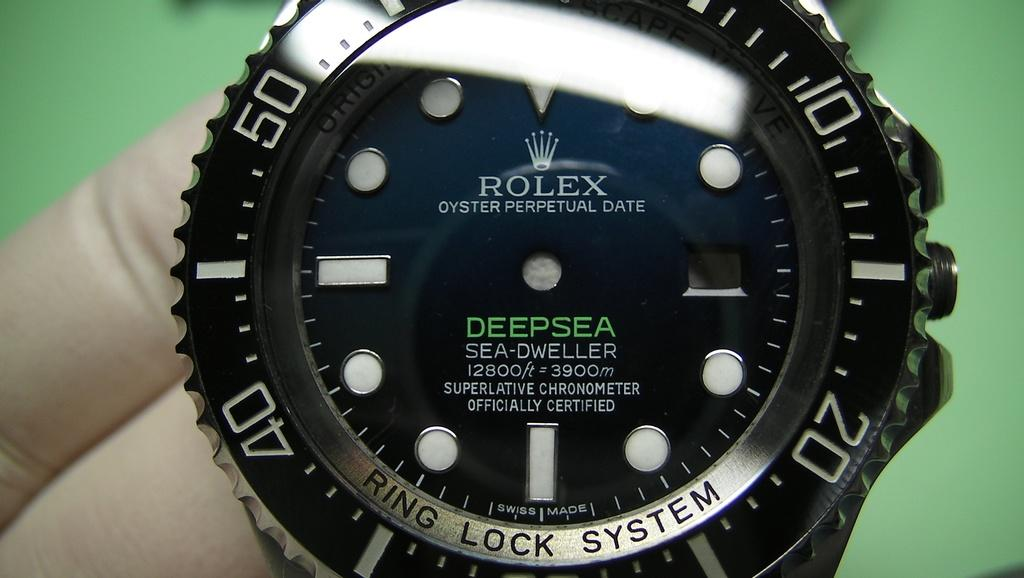<image>
Relay a brief, clear account of the picture shown. A person holding a black Rolex Deep Sea watch. 